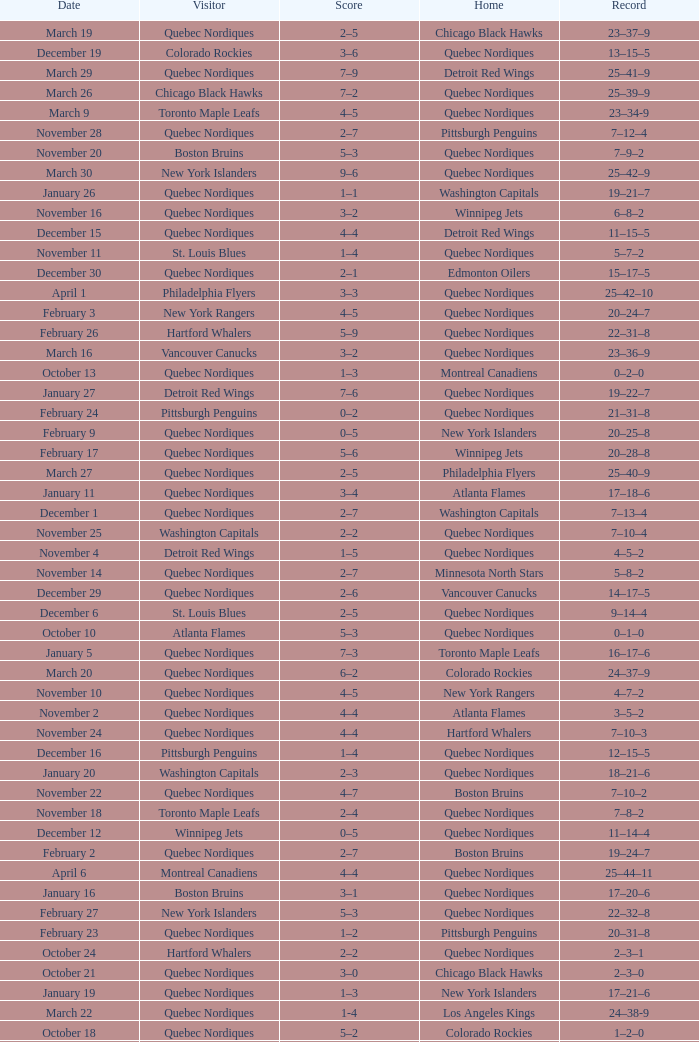Which Date has a Score of 2–7, and a Record of 5–8–2? November 14. 